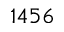<formula> <loc_0><loc_0><loc_500><loc_500>1 4 5 6</formula> 